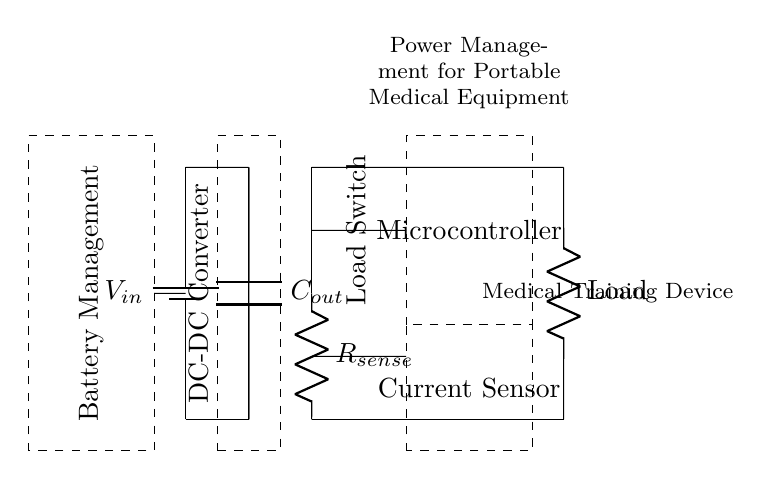What is the purpose of the DC-DC converter in this circuit? The DC-DC converter is responsible for converting the input voltage to a suitable output voltage level that can be used by the load, ensuring stable power delivery for portable medical equipment.
Answer: To convert input voltage What is the value of the output capacitor labeled in the circuit? The output capacitor is labeled as Cout, which indicates its role in smoothing the output voltage and filtering out voltage ripples. The specific value is not given in the diagram.
Answer: Cout What component acts as a load switch in the circuit? The load switch is represented by the element labeled "Load Switch," which controls the connection between the power source and the load, enabling or disabling power delivery to the load based on the system's requirements.
Answer: Load Switch What is the function of the current sensor in this circuit design? The current sensor, indicated in the circuit, measures the electrical current flowing through the load. It provides feedback to the microcontroller for monitoring and controlling power usage, which is essential for efficient operation of portable medical equipment.
Answer: To measure current How does the battery management system influence the circuit? The battery management system ensures proper charging and discharging of the battery, maintaining battery health and prolonging the lifespan. It manages voltage levels and prevents overcharge or deep discharge conditions, critical for the reliability of medical devices.
Answer: Manages battery health What type of load is indicated in the circuit? The load is represented by a resistor (labeled "Load"), which signifies it could be a medical training device consuming a specific amount of power from the available voltage in the circuit.
Answer: Medical Training Device 